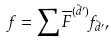<formula> <loc_0><loc_0><loc_500><loc_500>f = \sum \overline { F } ^ { ( \vec { d } ^ { \prime } ) } f _ { \vec { d } ^ { \prime } } ,</formula> 